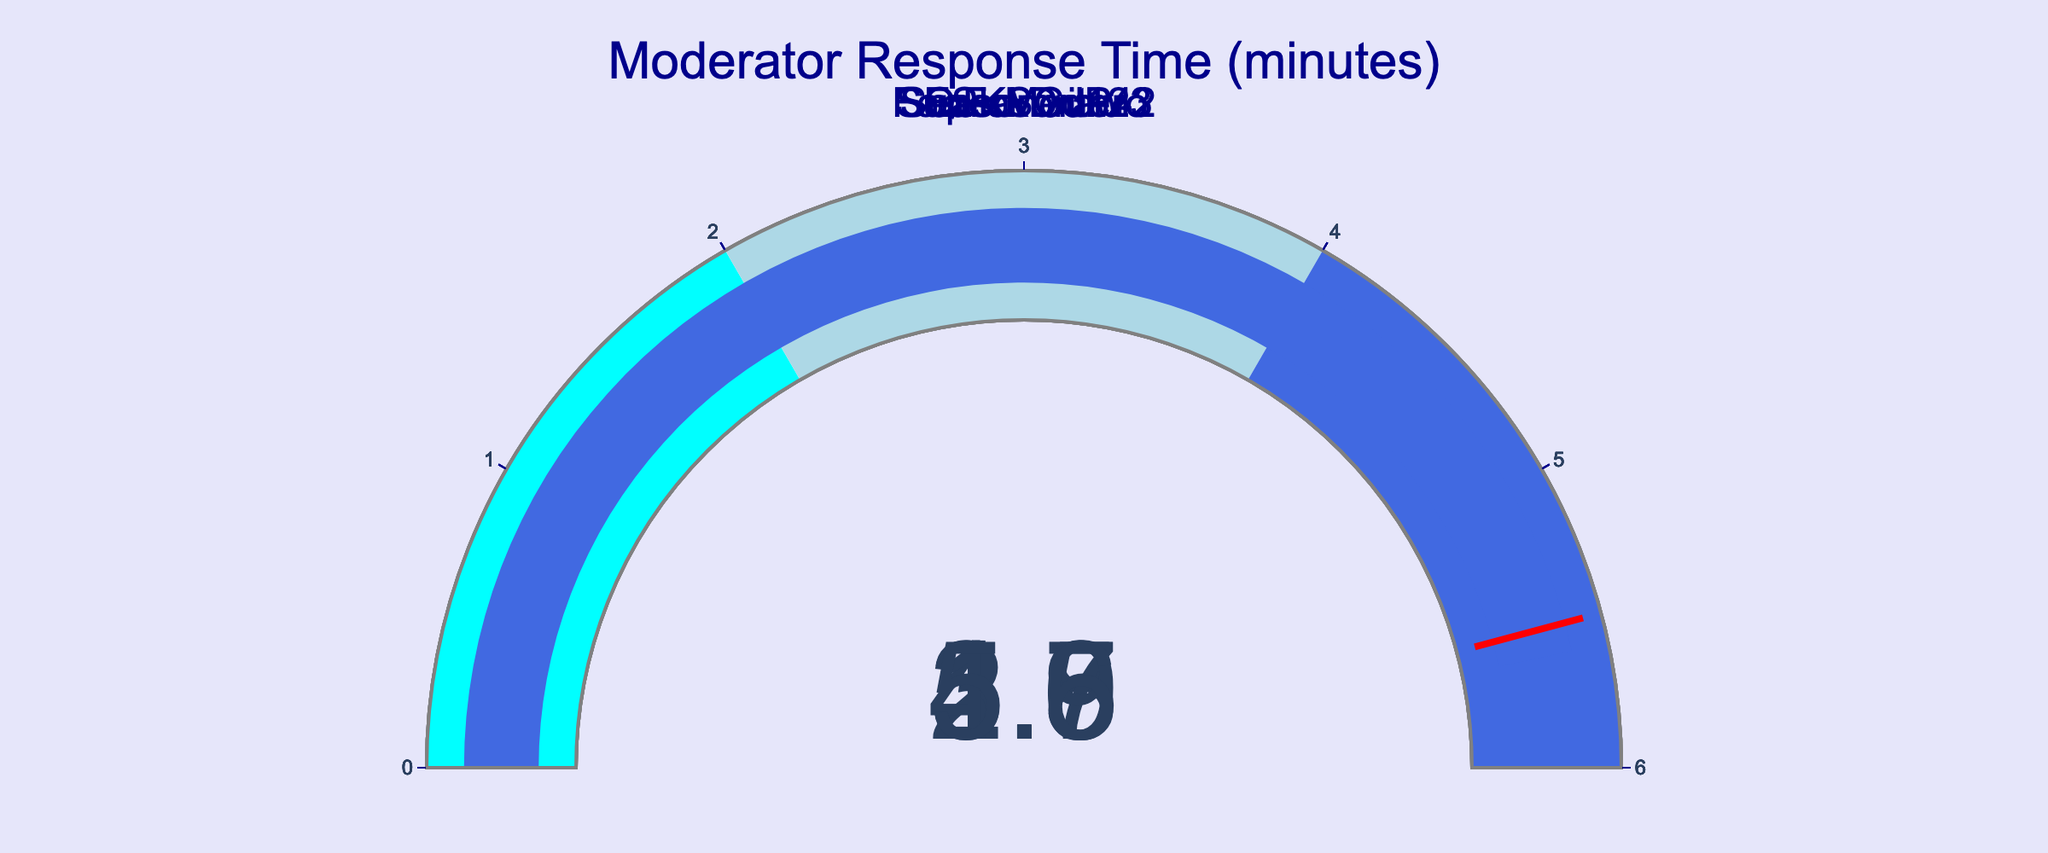What is the title of the figure? The title of the figure is located at the top and it provides a summary of the chart's purpose. The text is "Moderator Response Time (minutes)."
Answer: Moderator Response Time (minutes) How many moderators are displayed in the figure? Count the number of gauges, each representing one moderator. There are five gauges in total.
Answer: 5 Which moderator has the fastest response time? Locate the gauge with the lowest value, which is QuickDraw with a response time of 1.9 minutes.
Answer: QuickDraw Which moderator has the slowest response time? Identify the gauge with the highest value, which is SeasonedPro with a response time of 5.6 minutes.
Answer: SeasonedPro What is the average response time of the moderators? Add up all the response times: 2.5 + 4.8 + 3.7 + 1.9 + 5.6 = 18.5. Then divide by the number of moderators: 18.5 / 5 = 3.7 minutes.
Answer: 3.7 minutes Is any moderator's response time above the threshold of 5.5 minutes marked on the gauges? Check the threshold line at 5.5 minutes. Only SeasonedPro's response time of 5.6 minutes crosses this threshold.
Answer: Yes, SeasonedPro What's the difference in response time between SuperMod123 and FanFavorite42? Subtract the response time of FanFavorite42 from that of SuperMod123: 2.5 - 3.7 = -1.2. The difference is 1.2 minutes with FanFavorite42 being slower.
Answer: 1.2 minutes How many moderators have response times within the range of 2 to 4 minutes? Count the gauges whose values fall between 2 and 4. These are SuperMod123 (2.5), ESKSGuru (4.8), and FanFavorite42 (3.7). Three moderators fall within this range.
Answer: 3 Which moderator has the second fastest response time? Identify the second lowest value after QuickDraw. The second lowest response time is for SuperMod123 with 2.5 minutes.
Answer: SuperMod123 Do most moderators have response times under 4 minutes? Count the number of moderators with response times less than 4 minutes: QuickDraw (1.9), SuperMod123 (2.5), and FanFavorite42 (3.7). Three out of five moderators have response times under 4 minutes, which is the majority.
Answer: Yes 